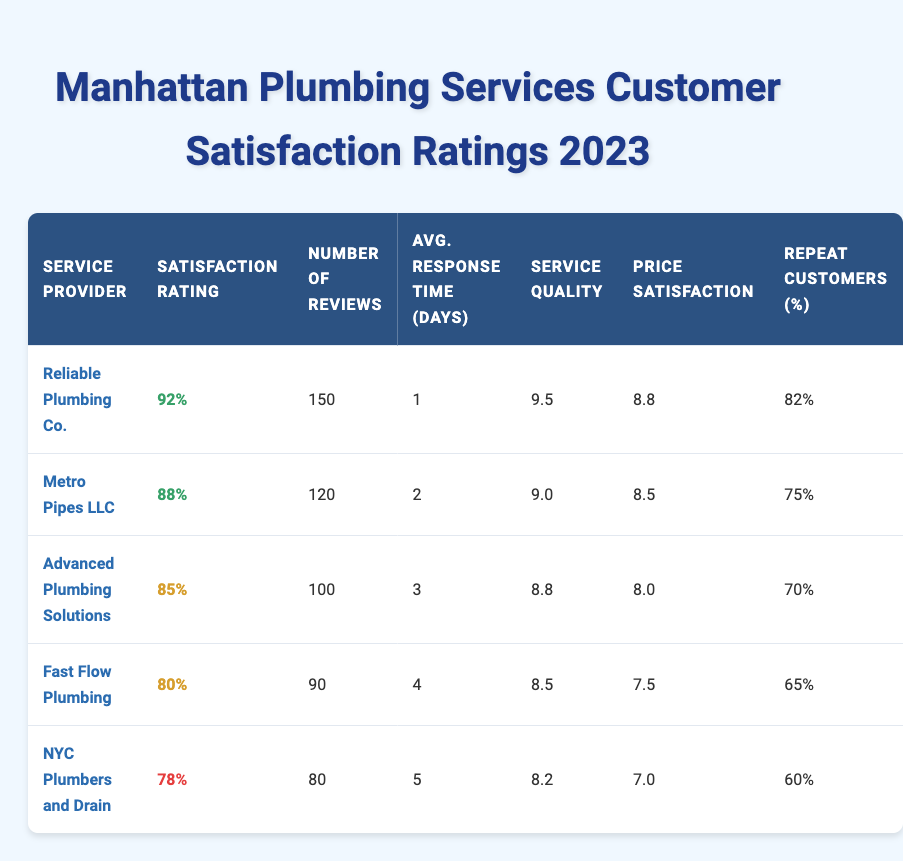What is the satisfaction rating for Reliable Plumbing Co.? The table shows that Reliable Plumbing Co. has a satisfaction rating of 92%.
Answer: 92% How many reviews did Advanced Plumbing Solutions receive? According to the table, Advanced Plumbing Solutions received a total of 100 reviews.
Answer: 100 Which plumbing service has the highest repeat customers percentage? By comparing the repeat customers percentage column, Reliable Plumbing Co. has the highest percentage at 82%.
Answer: 82% What is the average response time of Fast Flow Plumbing? The table indicates that Fast Flow Plumbing has an average response time of 4 days.
Answer: 4 Is the satisfaction rating of NYC Plumbers and Drain higher than 80%? The table states that NYC Plumbers and Drain has a satisfaction rating of 78%, which is lower than 80%.
Answer: No What is the average service quality rating for the top three plumbing services? The service quality ratings for the top three services are 9.5 (Reliable Plumbing Co.), 9.0 (Metro Pipes LLC), and 8.8 (Advanced Plumbing Solutions). Summing these gives 9.5 + 9.0 + 8.8 = 27.3. Dividing by 3 gives an average of 27.3 / 3 = 9.1.
Answer: 9.1 What is the difference in satisfaction rating between Reliable Plumbing Co. and Fast Flow Plumbing? Reliable Plumbing Co. has a satisfaction rating of 92%, while Fast Flow Plumbing has a rating of 80%. The difference is 92% - 80% = 12%.
Answer: 12% Does Metro Pipes LLC have an average response time of more than 2 days? The data shows that Metro Pipes LLC has an average response time of 2 days, which is not more than 2 days.
Answer: No What is the average price satisfaction of plumbing services listed in the table? The price satisfaction ratings are 8.8 (Reliable Plumbing Co.), 8.5 (Metro Pipes LLC), 8.0 (Advanced Plumbing Solutions), 7.5 (Fast Flow Plumbing), and 7.0 (NYC Plumbers and Drain). Summing these gives 8.8 + 8.5 + 8.0 + 7.5 + 7.0 = 39.8. Dividing by 5 gives an average of 39.8 / 5 = 7.96.
Answer: 7.96 